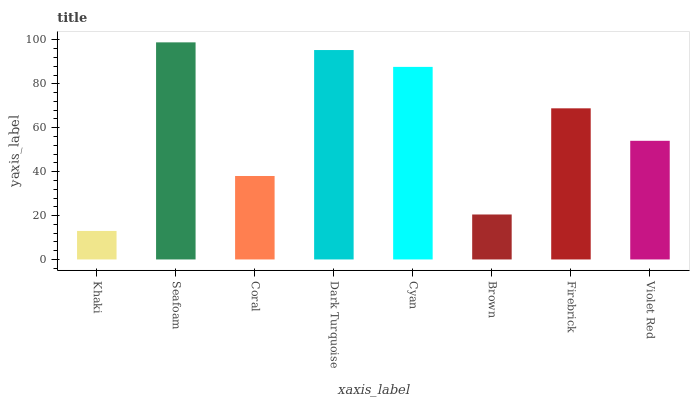Is Khaki the minimum?
Answer yes or no. Yes. Is Seafoam the maximum?
Answer yes or no. Yes. Is Coral the minimum?
Answer yes or no. No. Is Coral the maximum?
Answer yes or no. No. Is Seafoam greater than Coral?
Answer yes or no. Yes. Is Coral less than Seafoam?
Answer yes or no. Yes. Is Coral greater than Seafoam?
Answer yes or no. No. Is Seafoam less than Coral?
Answer yes or no. No. Is Firebrick the high median?
Answer yes or no. Yes. Is Violet Red the low median?
Answer yes or no. Yes. Is Brown the high median?
Answer yes or no. No. Is Dark Turquoise the low median?
Answer yes or no. No. 